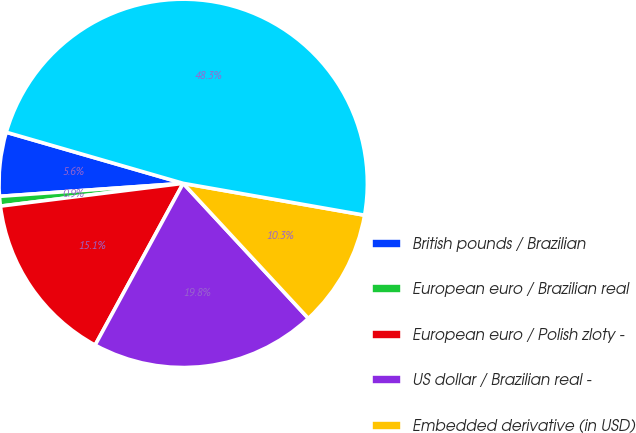Convert chart to OTSL. <chart><loc_0><loc_0><loc_500><loc_500><pie_chart><fcel>British pounds / Brazilian<fcel>European euro / Brazilian real<fcel>European euro / Polish zloty -<fcel>US dollar / Brazilian real -<fcel>Embedded derivative (in USD)<fcel>Indian rupee / US dollar<nl><fcel>5.6%<fcel>0.85%<fcel>15.09%<fcel>19.83%<fcel>10.34%<fcel>48.29%<nl></chart> 